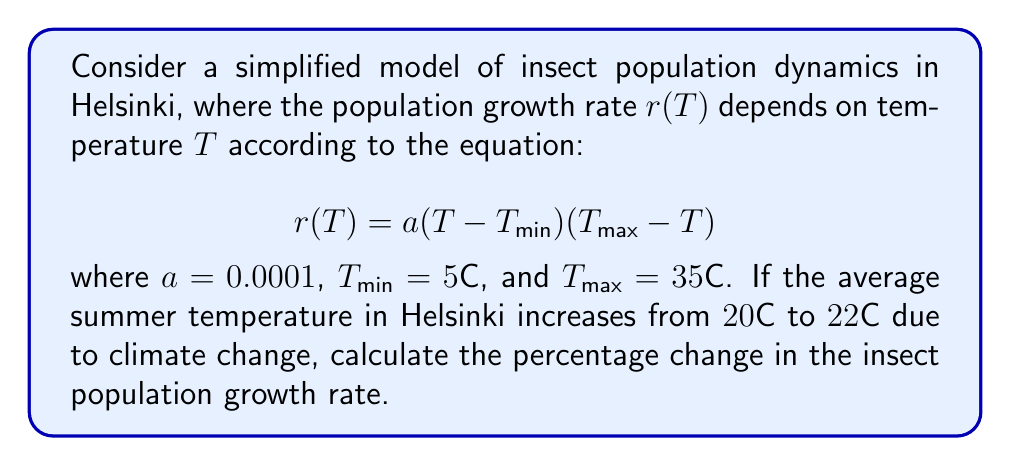Could you help me with this problem? To solve this problem, we'll follow these steps:

1) First, let's calculate the growth rate at the initial temperature of $20°C$:

   $$r(20) = 0.0001(20-5)(35-20) = 0.0001 \times 15 \times 15 = 0.0225$$

2) Now, let's calculate the growth rate at the new temperature of $22°C$:

   $$r(22) = 0.0001(22-5)(35-22) = 0.0001 \times 17 \times 13 = 0.0221$$

3) To find the percentage change, we use the formula:

   $$\text{Percentage Change} = \frac{\text{New Value} - \text{Original Value}}{\text{Original Value}} \times 100\%$$

4) Substituting our values:

   $$\text{Percentage Change} = \frac{0.0221 - 0.0225}{0.0225} \times 100\% = -1.78\%$$

5) The negative value indicates a decrease in the growth rate.
Answer: -1.78% 